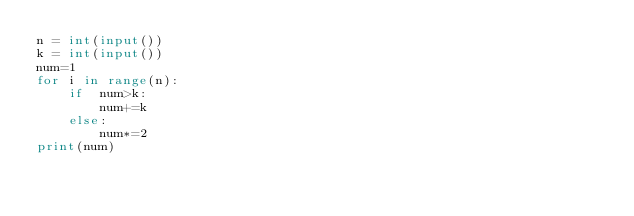Convert code to text. <code><loc_0><loc_0><loc_500><loc_500><_Python_>n = int(input())
k = int(input())
num=1
for i in range(n):
    if  num>k:
        num+=k
    else:
        num*=2
print(num)</code> 